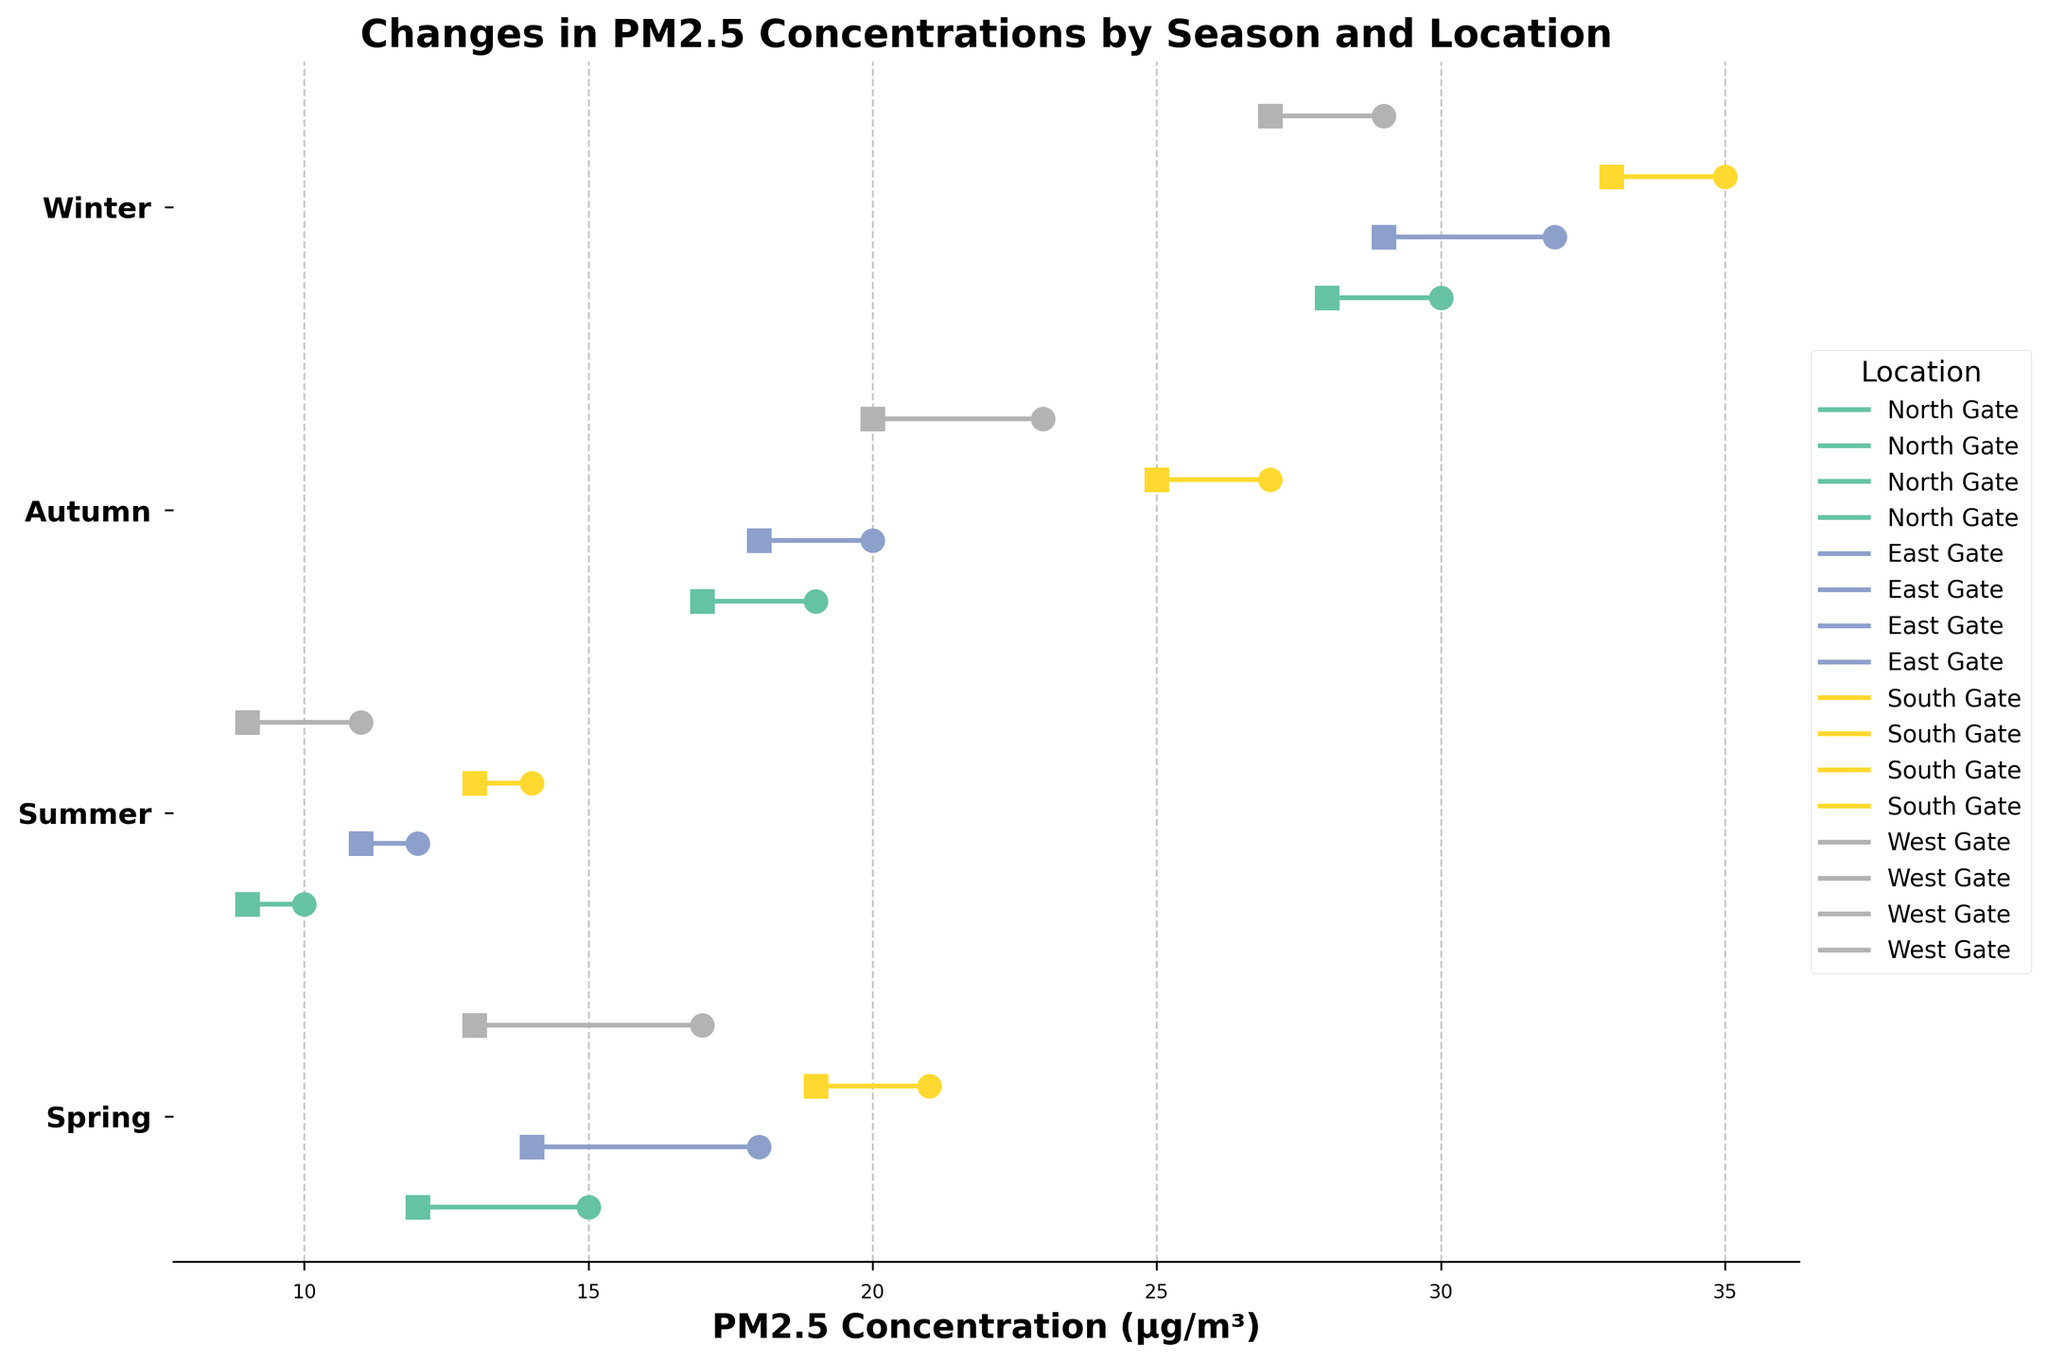What is the title of the plot? The title of the plot is located at the top center of the figure. It is 'Changes in PM2.5 Concentrations by Season and Location'.
Answer: Changes in PM2.5 Concentrations by Season and Location Which season has the highest starting PM2.5 concentration at the South Gate? In the plot, locate the dumbbells for the South Gate and identify their starting points. The winter starting point for South Gate is the highest.
Answer: Winter Which gate had the smallest decrease in PM2.5 concentration during autumn? Compare the start and end points for each gate during autumn. The South Gate has a decrease of 2 µg/m³ (27 - 25), which is the smallest difference.
Answer: South Gate What is the overall trend in PM2.5 concentration from start to end in summer? Look at the dumbbells' start and end points for each gate in summer. All gates show a decrease in PM2.5 concentrations.
Answer: Decrease What was the PM2.5 concentration reduction from spring to winter at the East Gate? Identify the start and end points for the East Gate in spring and winter, then calculate the reduction: (18 + 32) - (14 + 29) = 50 - 43 = 7 µg/m³.
Answer: 7 µg/m³ Which season has the smallest variation in PM2.5 concentrations for all gates? For each season, look at the range between the highest and lowest PM2.5 values for all gates. Summer has the smallest variation.
Answer: Summer Which location had the highest PM2.5 concentration by the end of winter? Locate the end points of all gates in the winter season. The South Gate has the highest end concentration with 33 µg/m³.
Answer: South Gate How many total locations are monitored in the data? Count the distinct locations mentioned in the plot. There are four: North Gate, East Gate, South Gate, and West Gate.
Answer: Four Are there any gates where the PM2.5 concentration increased from start to end within any given season? Examine all dumbbells to see if any end point is higher than its start point. No such increase is observed in any season.
Answer: No 